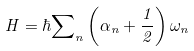Convert formula to latex. <formula><loc_0><loc_0><loc_500><loc_500>H = \hbar { \sum } _ { n } \left ( \alpha _ { n } + \frac { 1 } { 2 } \right ) \omega _ { n }</formula> 